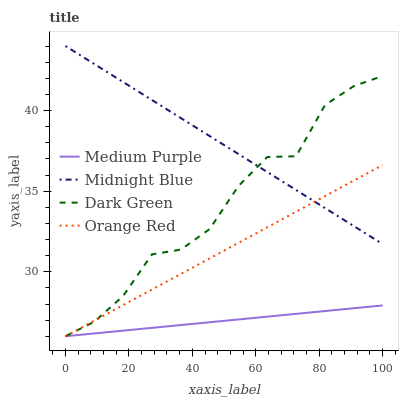Does Medium Purple have the minimum area under the curve?
Answer yes or no. Yes. Does Midnight Blue have the maximum area under the curve?
Answer yes or no. Yes. Does Orange Red have the minimum area under the curve?
Answer yes or no. No. Does Orange Red have the maximum area under the curve?
Answer yes or no. No. Is Midnight Blue the smoothest?
Answer yes or no. Yes. Is Dark Green the roughest?
Answer yes or no. Yes. Is Orange Red the smoothest?
Answer yes or no. No. Is Orange Red the roughest?
Answer yes or no. No. Does Medium Purple have the lowest value?
Answer yes or no. Yes. Does Midnight Blue have the lowest value?
Answer yes or no. No. Does Midnight Blue have the highest value?
Answer yes or no. Yes. Does Orange Red have the highest value?
Answer yes or no. No. Is Medium Purple less than Midnight Blue?
Answer yes or no. Yes. Is Midnight Blue greater than Medium Purple?
Answer yes or no. Yes. Does Dark Green intersect Medium Purple?
Answer yes or no. Yes. Is Dark Green less than Medium Purple?
Answer yes or no. No. Is Dark Green greater than Medium Purple?
Answer yes or no. No. Does Medium Purple intersect Midnight Blue?
Answer yes or no. No. 